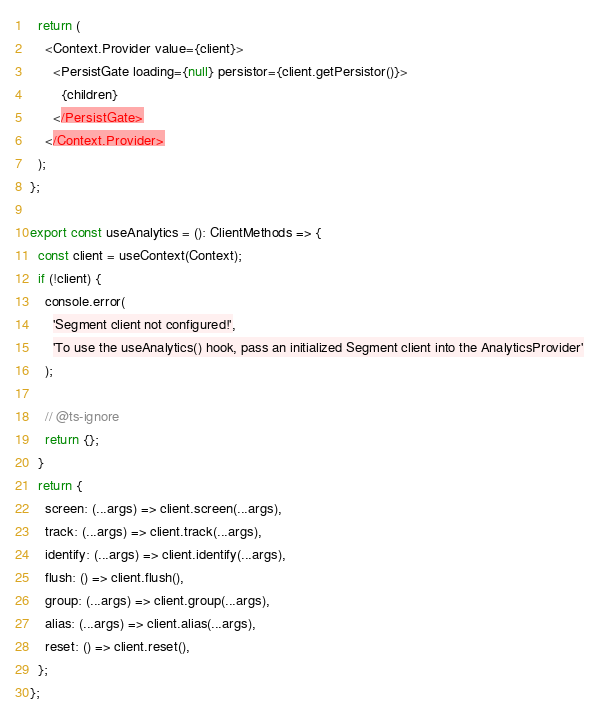Convert code to text. <code><loc_0><loc_0><loc_500><loc_500><_TypeScript_>  return (
    <Context.Provider value={client}>
      <PersistGate loading={null} persistor={client.getPersistor()}>
        {children}
      </PersistGate>
    </Context.Provider>
  );
};

export const useAnalytics = (): ClientMethods => {
  const client = useContext(Context);
  if (!client) {
    console.error(
      'Segment client not configured!',
      'To use the useAnalytics() hook, pass an initialized Segment client into the AnalyticsProvider'
    );

    // @ts-ignore
    return {};
  }
  return {
    screen: (...args) => client.screen(...args),
    track: (...args) => client.track(...args),
    identify: (...args) => client.identify(...args),
    flush: () => client.flush(),
    group: (...args) => client.group(...args),
    alias: (...args) => client.alias(...args),
    reset: () => client.reset(),
  };
};
</code> 